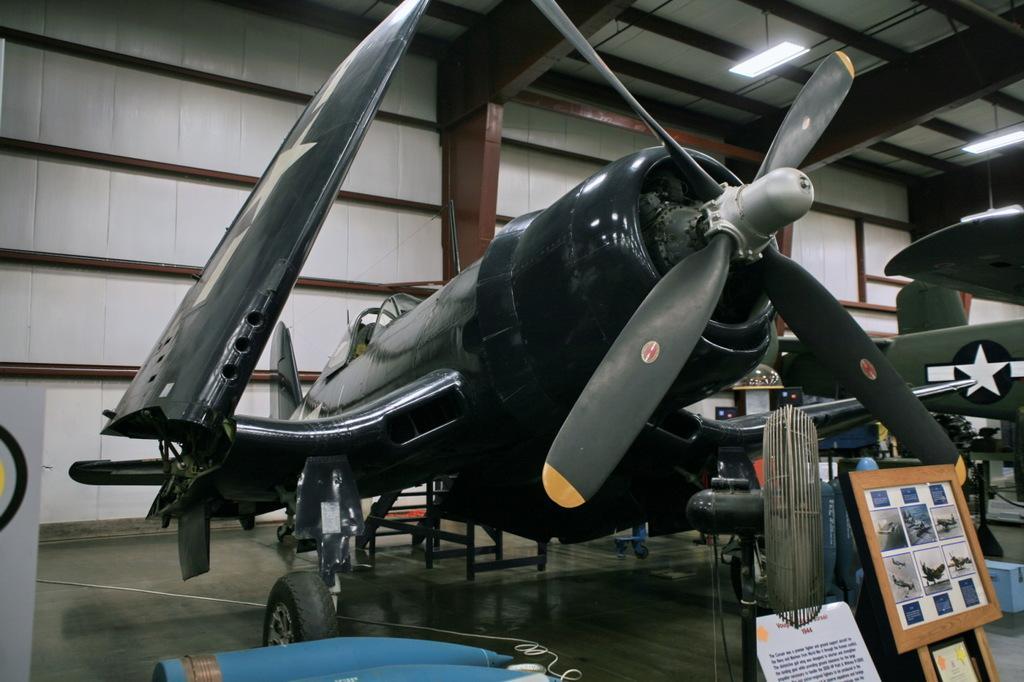Could you give a brief overview of what you see in this image? In this picture there is an airplane which is in the center. On the right side there is a frame and there is a fan. In the center on the ground there are objects which are blue in colour. On the top there are lights hanging and on the right side in the front there is some text written on the object which is white in colour. 